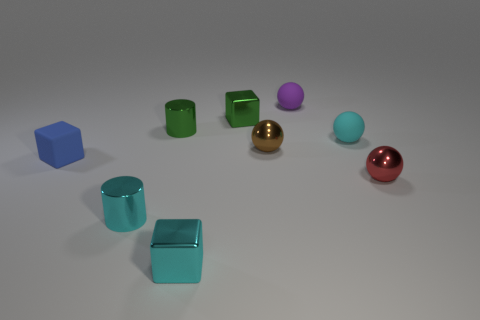Are there any patterns or symmetry in the arrangement of the objects? The objects are arranged without any apparent symmetry or pattern, though there is a loosely scattered configuration that balances the composition of the scene. The objects’ varying positions and orientations contribute to a casual, random aesthetic. 